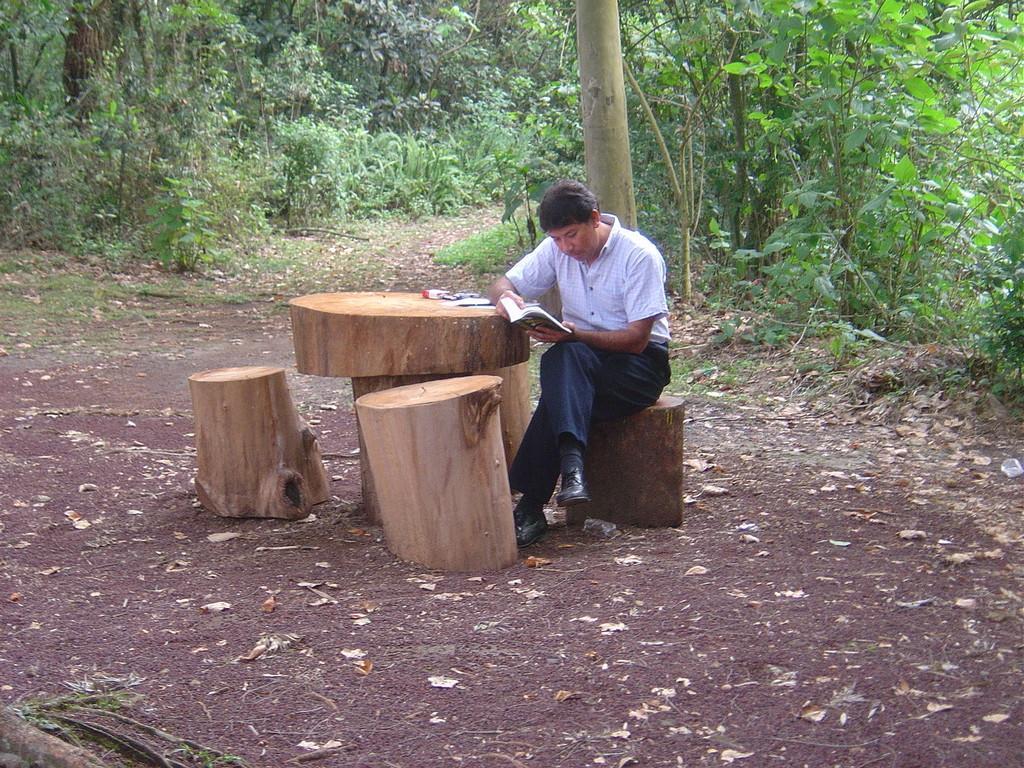In one or two sentences, can you explain what this image depicts? In this image in the center there is one person who is sitting, and there are some wooden sticks at the bottom there is grass and some dry leaves. And in the background there are some trees. 